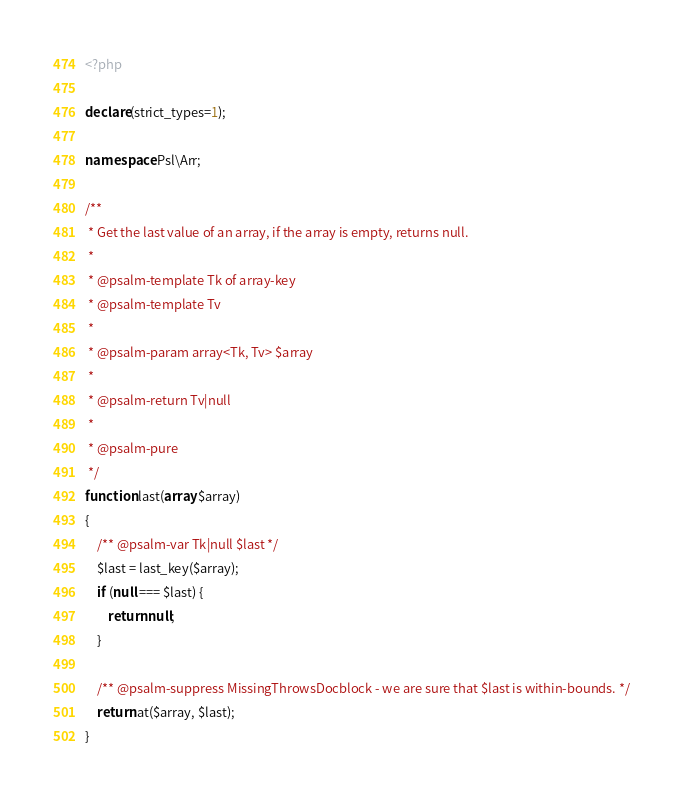Convert code to text. <code><loc_0><loc_0><loc_500><loc_500><_PHP_><?php

declare(strict_types=1);

namespace Psl\Arr;

/**
 * Get the last value of an array, if the array is empty, returns null.
 *
 * @psalm-template Tk of array-key
 * @psalm-template Tv
 *
 * @psalm-param array<Tk, Tv> $array
 *
 * @psalm-return Tv|null
 *
 * @psalm-pure
 */
function last(array $array)
{
    /** @psalm-var Tk|null $last */
    $last = last_key($array);
    if (null === $last) {
        return null;
    }

    /** @psalm-suppress MissingThrowsDocblock - we are sure that $last is within-bounds. */
    return at($array, $last);
}
</code> 